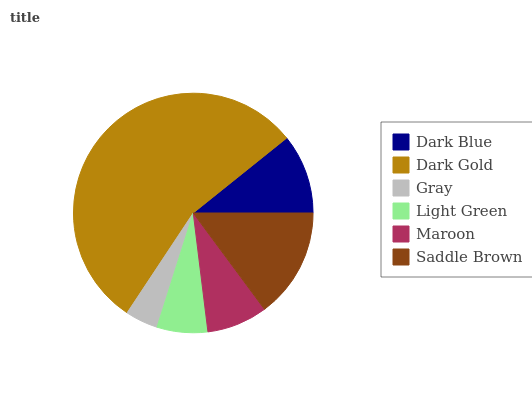Is Gray the minimum?
Answer yes or no. Yes. Is Dark Gold the maximum?
Answer yes or no. Yes. Is Dark Gold the minimum?
Answer yes or no. No. Is Gray the maximum?
Answer yes or no. No. Is Dark Gold greater than Gray?
Answer yes or no. Yes. Is Gray less than Dark Gold?
Answer yes or no. Yes. Is Gray greater than Dark Gold?
Answer yes or no. No. Is Dark Gold less than Gray?
Answer yes or no. No. Is Dark Blue the high median?
Answer yes or no. Yes. Is Maroon the low median?
Answer yes or no. Yes. Is Dark Gold the high median?
Answer yes or no. No. Is Dark Blue the low median?
Answer yes or no. No. 